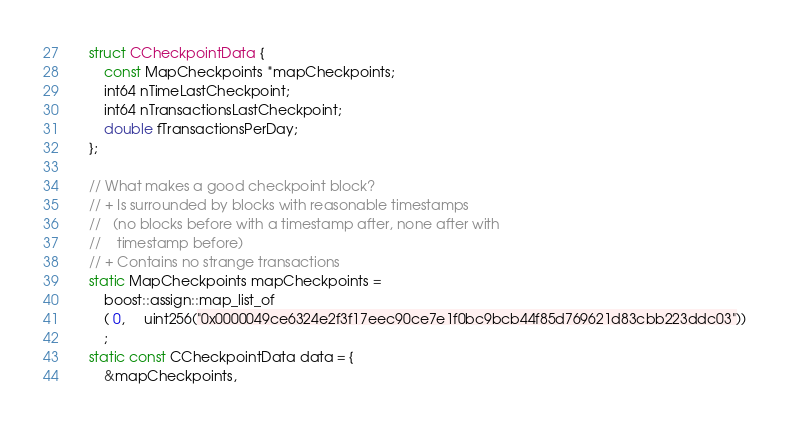Convert code to text. <code><loc_0><loc_0><loc_500><loc_500><_C++_>    struct CCheckpointData {
        const MapCheckpoints *mapCheckpoints;
        int64 nTimeLastCheckpoint;
        int64 nTransactionsLastCheckpoint;
        double fTransactionsPerDay;
    };

    // What makes a good checkpoint block?
    // + Is surrounded by blocks with reasonable timestamps
    //   (no blocks before with a timestamp after, none after with
    //    timestamp before)
    // + Contains no strange transactions
    static MapCheckpoints mapCheckpoints =
        boost::assign::map_list_of
        ( 0,     uint256("0x0000049ce6324e2f3f17eec90ce7e1f0bc9bcb44f85d769621d83cbb223ddc03"))
        ;
    static const CCheckpointData data = {
        &mapCheckpoints,</code> 